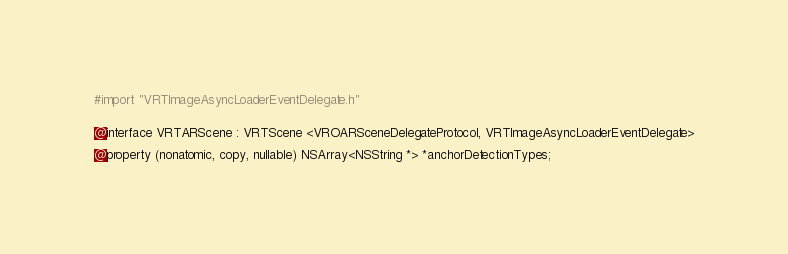Convert code to text. <code><loc_0><loc_0><loc_500><loc_500><_C_>#import "VRTImageAsyncLoaderEventDelegate.h"


@interface VRTARScene : VRTScene <VROARSceneDelegateProtocol, VRTImageAsyncLoaderEventDelegate>

@property (nonatomic, copy, nullable) NSArray<NSString *> *anchorDetectionTypes;</code> 